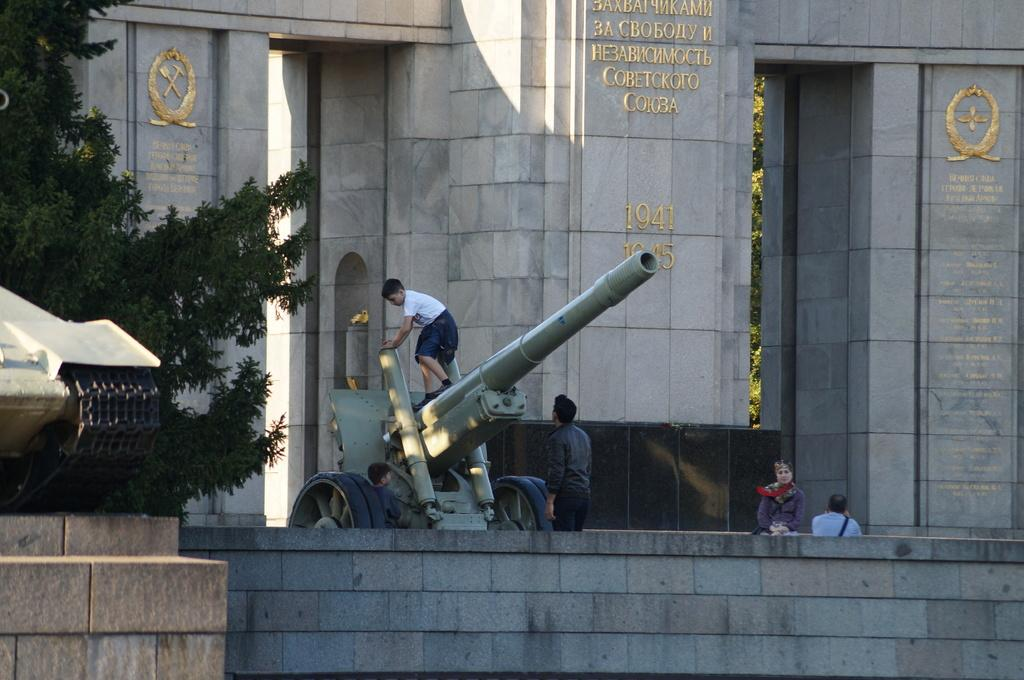What is the main subject of the image? The main subject of the image is a missile. What can be seen in the background of the image? There are trees in the image. Are there any people present in the image? Yes, there are people in the image. What is on the wall in the image? There are objects on the wall in the image. What type of leather is used to cover the missile in the image? There is no leather present on the missile in the image. 